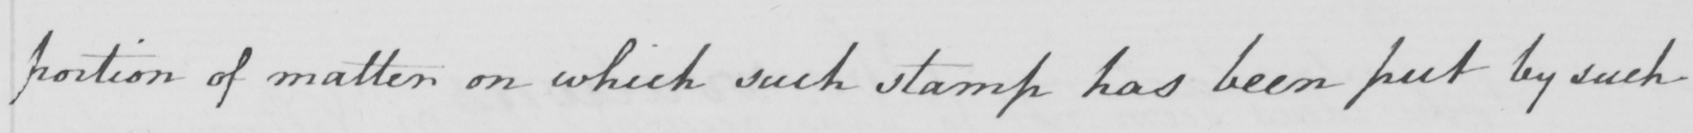Can you read and transcribe this handwriting? portion of matter on which such stamp has been put by such 